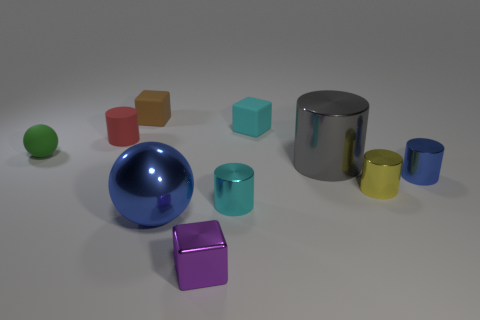Subtract all small shiny blocks. How many blocks are left? 2 Subtract all red cylinders. How many cylinders are left? 4 Subtract all cubes. How many objects are left? 7 Subtract 0 yellow spheres. How many objects are left? 10 Subtract all yellow blocks. Subtract all brown balls. How many blocks are left? 3 Subtract all blue objects. Subtract all tiny cylinders. How many objects are left? 4 Add 5 rubber cylinders. How many rubber cylinders are left? 6 Add 1 yellow objects. How many yellow objects exist? 2 